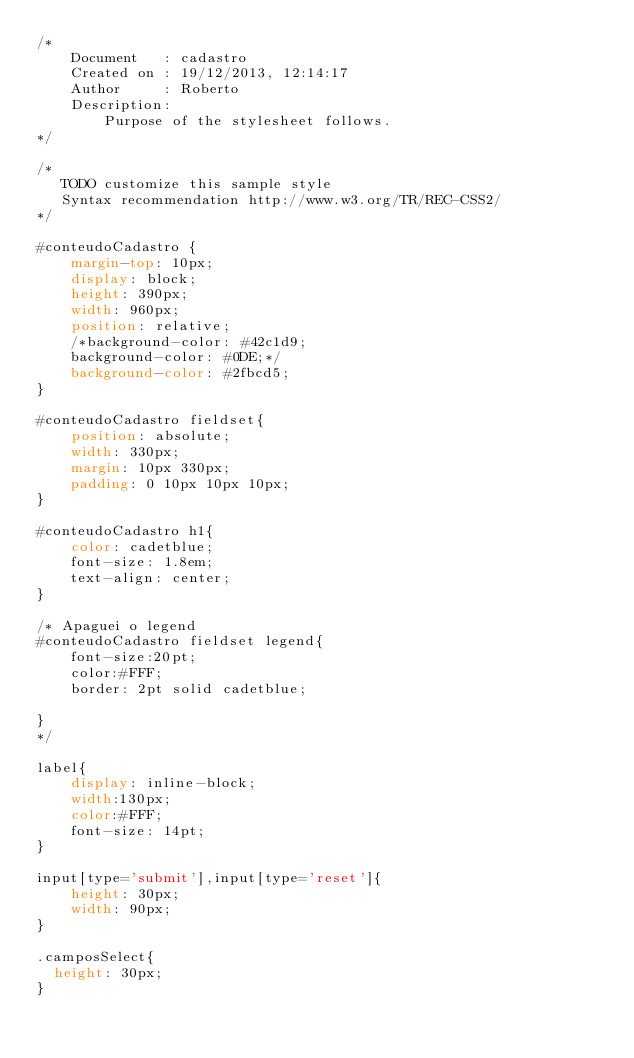Convert code to text. <code><loc_0><loc_0><loc_500><loc_500><_CSS_>/* 
    Document   : cadastro
    Created on : 19/12/2013, 12:14:17
    Author     : Roberto
    Description:
        Purpose of the stylesheet follows.
*/

/* 
   TODO customize this sample style
   Syntax recommendation http://www.w3.org/TR/REC-CSS2/
*/

#conteudoCadastro { 
    margin-top: 10px;
    display: block;
    height: 390px;
    width: 960px;
    position: relative;
    /*background-color: #42c1d9;
    background-color: #0DE;*/
    background-color: #2fbcd5;
}

#conteudoCadastro fieldset{
    position: absolute;
    width: 330px;
    margin: 10px 330px;
    padding: 0 10px 10px 10px;
}

#conteudoCadastro h1{
    color: cadetblue;
    font-size: 1.8em;
    text-align: center;
}

/* Apaguei o legend
#conteudoCadastro fieldset legend{
    font-size:20pt;
    color:#FFF;
    border: 2pt solid cadetblue;
    
}
*/

label{
    display: inline-block;
    width:130px;
    color:#FFF;
    font-size: 14pt;
}

input[type='submit'],input[type='reset']{
    height: 30px;
    width: 90px;
}

.camposSelect{
	height: 30px;
}
</code> 